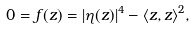<formula> <loc_0><loc_0><loc_500><loc_500>0 = f ( z ) = | \eta ( z ) | ^ { 4 } - \langle z , z \rangle ^ { 2 } ,</formula> 